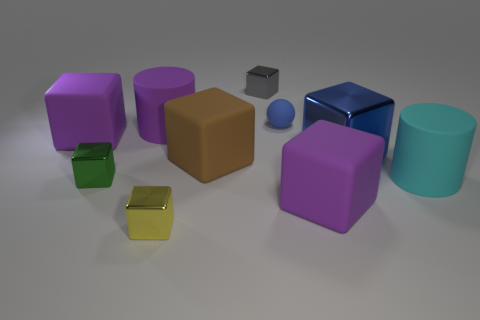What is the shape of the other object that is the same color as the small rubber object?
Ensure brevity in your answer.  Cube. What is the size of the blue thing that is behind the large purple thing that is left of the green object?
Your answer should be compact. Small. There is a tiny metal object right of the tiny yellow object; what is its color?
Provide a succinct answer. Gray. Is there another object that has the same shape as the yellow object?
Provide a succinct answer. Yes. Is the number of rubber blocks behind the big cyan matte cylinder less than the number of big things to the right of the small green thing?
Your answer should be very brief. Yes. The tiny matte ball has what color?
Keep it short and to the point. Blue. Is there a purple block to the right of the large rubber cylinder behind the big blue cube?
Offer a very short reply. Yes. What number of blue matte objects have the same size as the brown cube?
Offer a terse response. 0. What number of balls are on the left side of the metal cube that is to the right of the small metal object that is on the right side of the yellow metal cube?
Make the answer very short. 1. What number of large matte things are both behind the big brown thing and right of the large metallic object?
Ensure brevity in your answer.  0. 